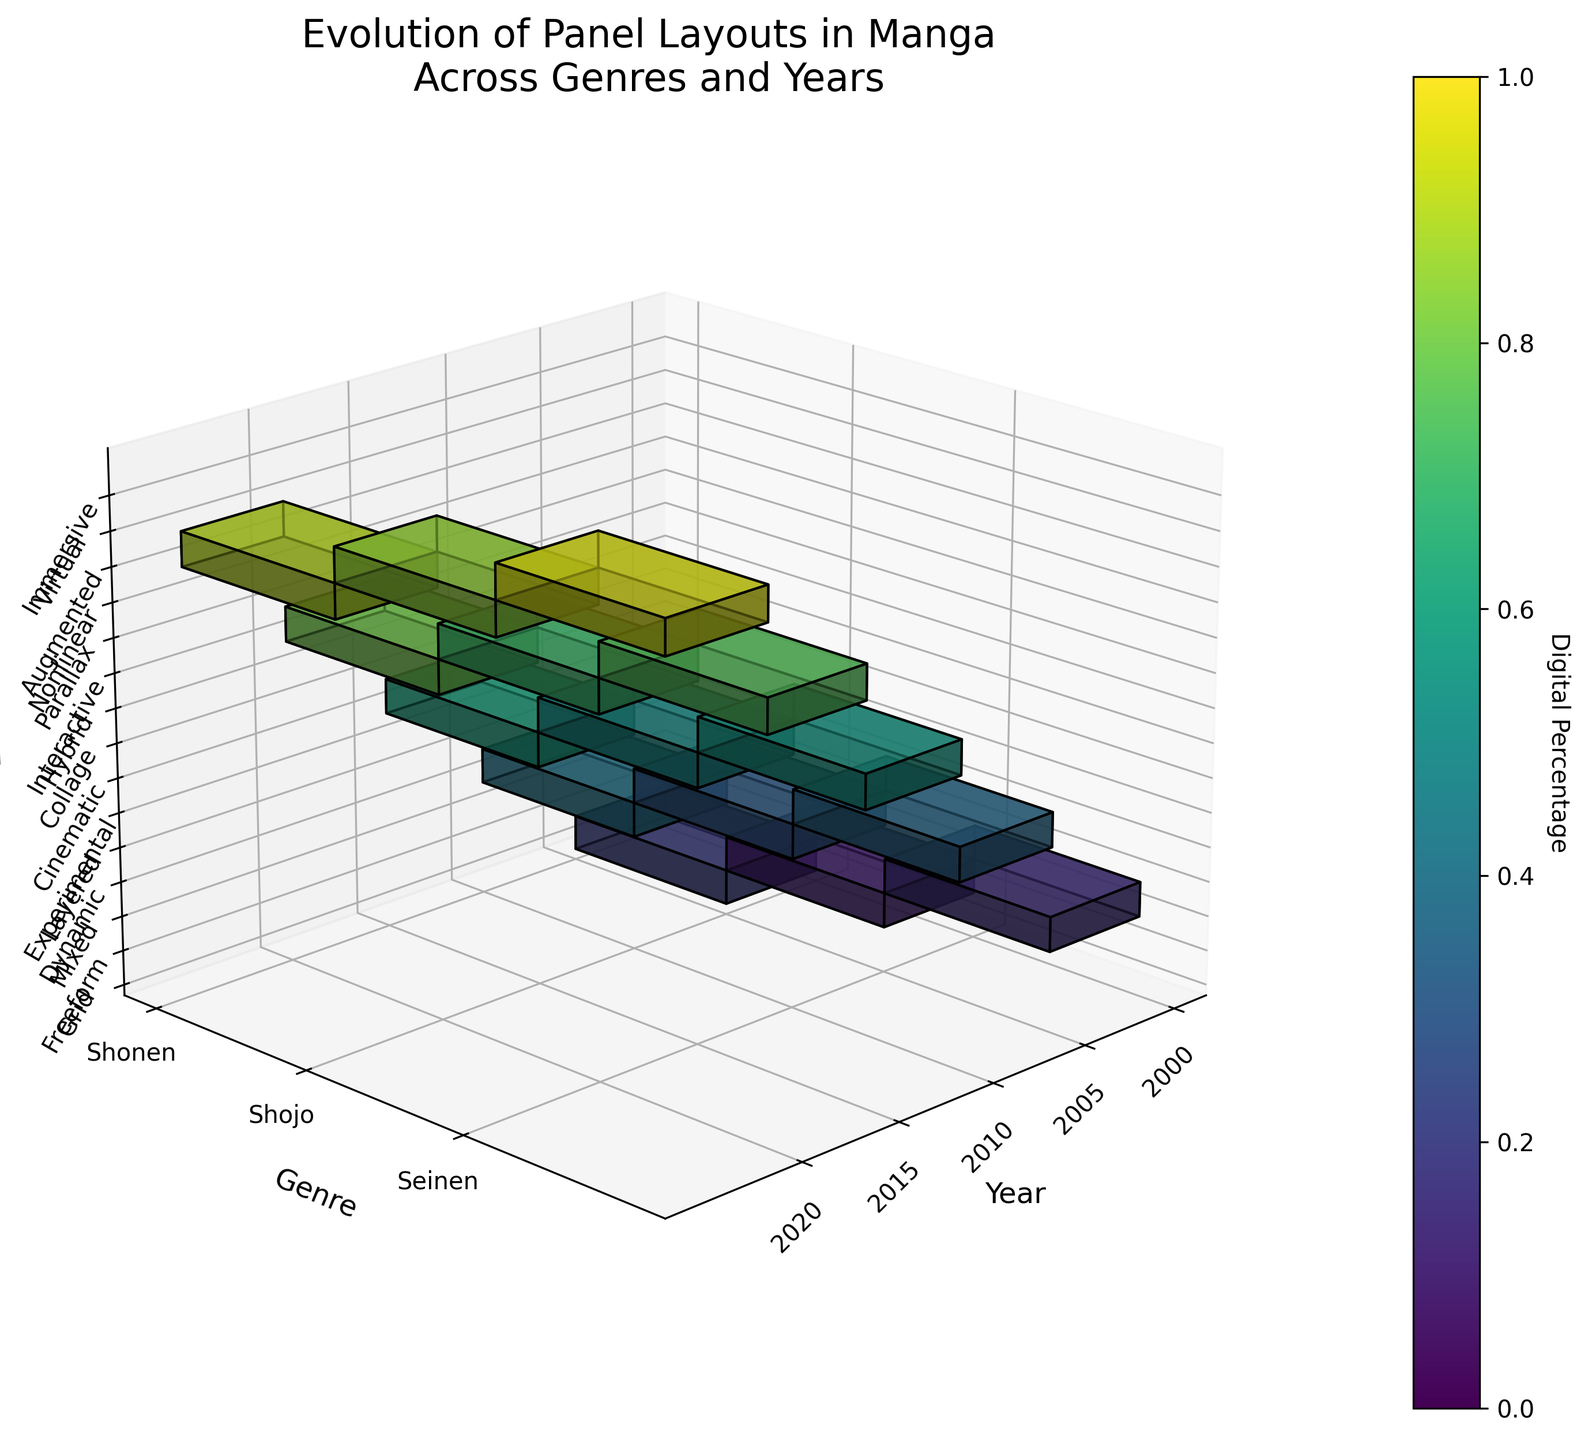what is the title of the figure? The title of the figure is located at the top center and describes the general content of the plot. It reads: 'Evolution of Panel Layouts in Manga Across Genres and Years.'
Answer: Evolution of Panel Layouts in Manga Across Genres and Years What are the unique genres represented in the plot? The genres are depicted along the y-axis of the 3D plot, which are labeled with the unique genres present in the data. These genres are Shonen, Shojo, and Seinen.
Answer: Shonen, Shojo, and Seinen Which year shows the highest digital percentage for the Seinen genre? By examining the color intensity for the Seinen genre across different years, the year 2020 has the darkest color, indicating the highest digital percentage. This is confirmed by the data as well.
Answer: 2020 How does the complexity score of Seinen layouts change from 2000 to 2020? The complexity scores of Seinen layouts can be traced along the timeline from 2000 to 2020: In 2000, it is 4, in 2005 it is 5, in 2010 it is 6, in 2015 it is 7, and in 2020 it is 8. The scores incrementally increase each period.
Answer: They increase from 4 to 8 Compare the digital percentages for Shonen and Shojo genres in 2015. Which one is higher? In 2015, the digital percentage for Shonen is represented by a darker color compared to Shojo. Shonen has 80% while Shojo has 70%. Therefore, Shonen has a higher digital percentage.
Answer: Shonen What trend do we observe in the layout complexity scores for the Shonen genre from 2000 to 2020? The complexity scores for the Shonen genre can be observed at each time mark: 2 in 2000, 3 in 2005, 4 in 2010, 5 in 2015, and 6 in 2020. The general trend shows a consistent increase in complexity over the years.
Answer: Increasing What is the most common layout type in the traditional percentage for the Shojo genre in the early 2000s? For Shojo in the year 2000, the data indicates 'Freeform' as the layout type with 90% traditional percentage.
Answer: Freeform Identify the layout type that appears in the Seinen genre with the highest digital percentage in 2020. The highest digital percentage in 2020 for Seinen is represented by the layout type 'Immersive', as indicated by the color intensity.
Answer: Immersive Assess how digital adoption in panel layouts varies between Shonen and Seinen genres in 2020. In 2020, analyzing the color intensity, the Shonen genre shows a digital percentage of 90%, while Seinen is at 95%. This shows that digital adoption is slightly higher in Seinen than in Shonen.
Answer: Seinen has higher adoption What is the general pattern of digital percentages for manga layouts from 2000 to 2020 across all genres? From 2000 to 2020, the color intensities for all genres (Shonen, Shojo, Seinen) progressively darken, reflecting increasing digital percentages with each subsequent year. The trend signifies a continuous rise in digital adoption.
Answer: Increasing 